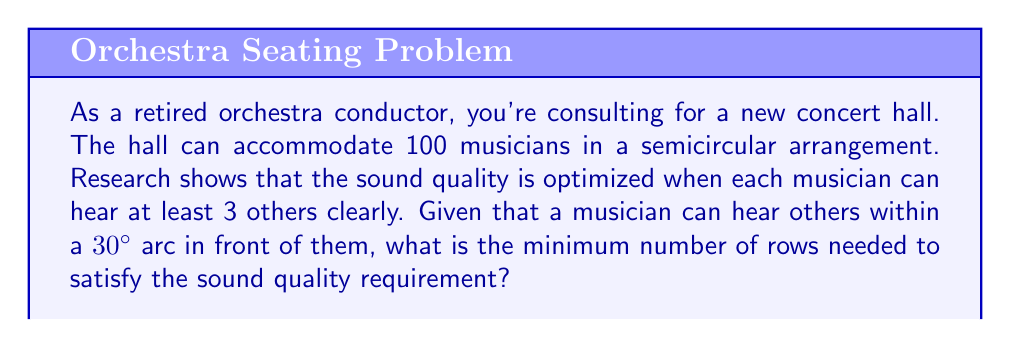Help me with this question. Let's approach this step-by-step:

1) In a semicircle, the total angle is 180°. If each musician occupies a 30° arc of hearing, we can fit at most $\frac{180°}{30°} = 6$ musicians in a single row.

2) Let's define variables:
   $n$ = number of rows
   $a_i$ = number of musicians in the $i$-th row (from the front)

3) The total number of musicians should sum to 100:

   $$\sum_{i=1}^n a_i = 100$$

4) Given the semicircular arrangement, each row will have fewer musicians than the one in front of it. We can approximate this as an arithmetic sequence:

   $$a_i = a_1 - (i-1)d$$

   where $d$ is the common difference.

5) The first row will have 6 musicians (as calculated in step 1), and the last row should have at least 1 musician. So:

   $$a_1 = 6$$
   $$a_n = 6 - (n-1)d \geq 1$$

6) From the arithmetic sequence formula:

   $$\sum_{i=1}^n a_i = \frac{n}{2}(a_1 + a_n) = 100$$

7) Substituting known values:

   $$\frac{n}{2}(6 + (6 - (n-1)d)) = 100$$

8) To satisfy the sound quality requirement, each musician needs to hear at least 3 others. This means each row needs at least 4 musicians (3 to be heard + the musician themselves).

9) So, $a_n \geq 4$, which means:

   $$6 - (n-1)d \geq 4$$
   $$(n-1)d \leq 2$$

10) Solving the equation from step 7 with this constraint leads to a minimum value of $n = 5$.
Answer: The minimum number of rows needed is 5. 